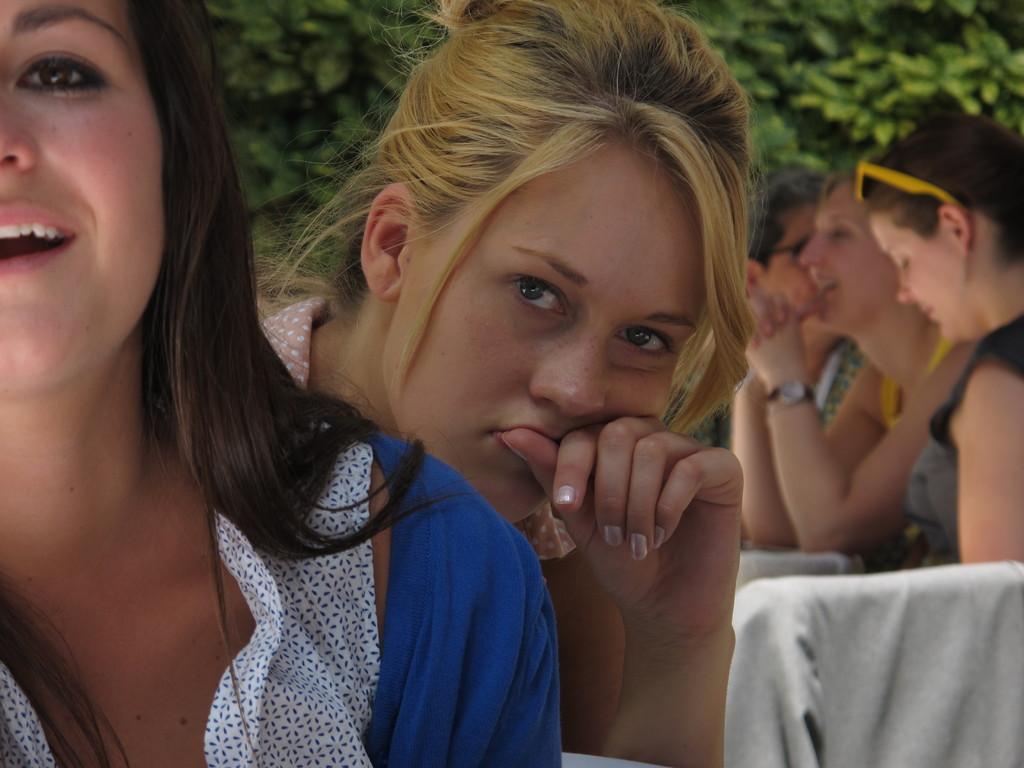Describe this image in one or two sentences. In this image we can see many people. One lady is wearing watch. Another lady is having goggles on the head. In the back we can see leaves. 